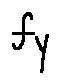Convert formula to latex. <formula><loc_0><loc_0><loc_500><loc_500>f y</formula> 